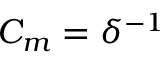Convert formula to latex. <formula><loc_0><loc_0><loc_500><loc_500>C _ { m } = \delta ^ { - 1 }</formula> 